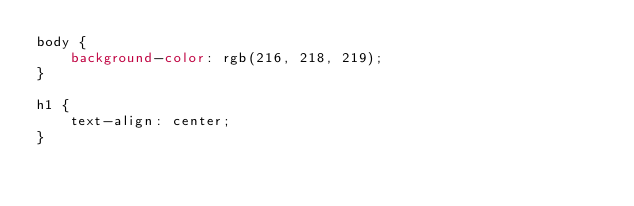Convert code to text. <code><loc_0><loc_0><loc_500><loc_500><_CSS_>body {
    background-color: rgb(216, 218, 219);
}

h1 {
    text-align: center;
}</code> 